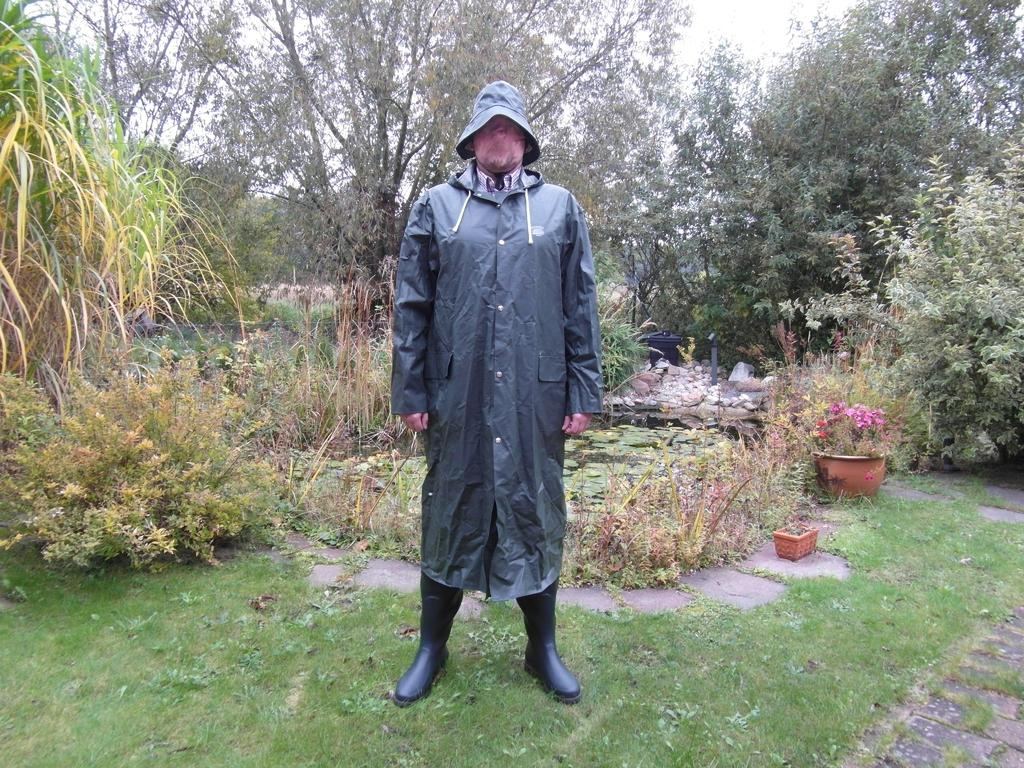What is the man in the image wearing? The man is wearing a coat and a hat. What can be seen in the background of the image? There are plant pots, plants, grass, trees, and the sky visible in the background of the image. Can you describe the natural environment in the image? The natural environment includes grass, trees, and the sky. What type of government is depicted in the image? There is no depiction of a government in the image; it features a man wearing a coat and a hat, with a natural background. 